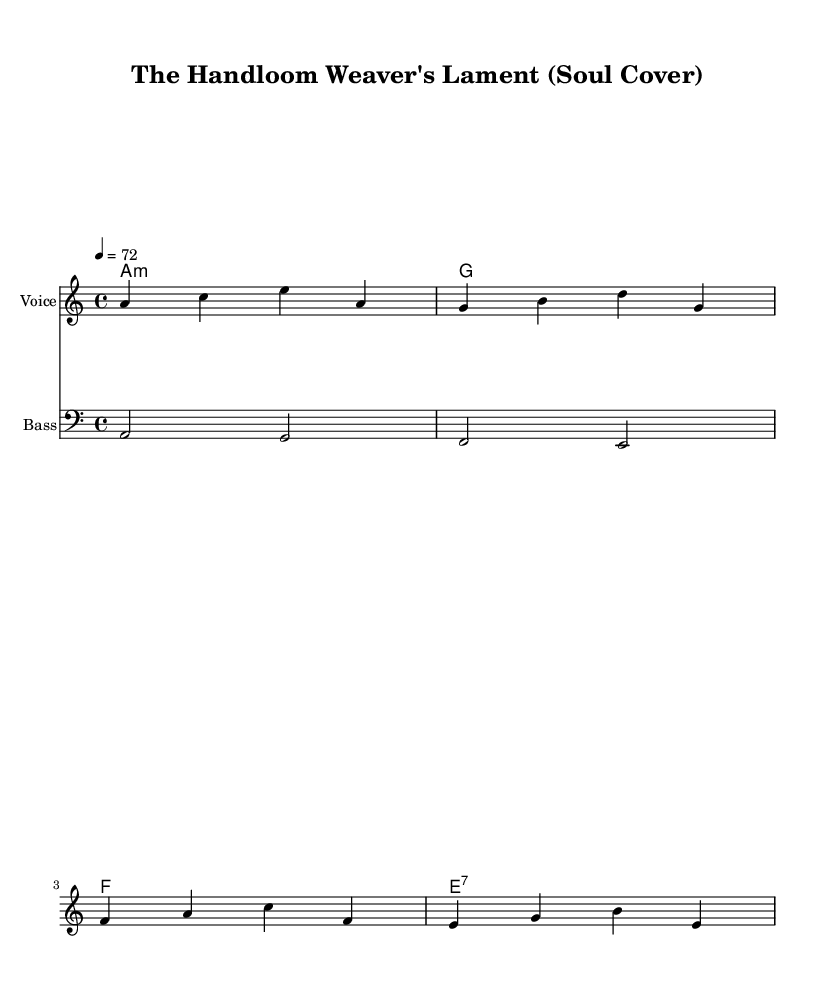What is the key signature of this music? The key signature is A minor, which is indicated by the absence of sharps and flats. A minor is the relative minor of C major.
Answer: A minor What is the time signature of this music? The time signature is 4/4, which indicates that there are four beats in each measure, and the quarter note gets one beat. This common time signature is identified at the beginning of the piece.
Answer: 4/4 What is the tempo marking indicated in the sheet music? The tempo marking shows 4 equals 72, meaning the music should be played at a speed of 72 beats per minute, which is a moderate pace.
Answer: 72 What chord follows the A minor in the harmonies? The chord that follows A minor in the listed chord progression is G major, which is the second chord in the sequence. This can be seen as the music moves through the harmonies.
Answer: G How many measures are in the melody section? The melody section contains four measures, as indicated by the grouping of four sets of notes written before the bar lines. Each grouping constitutes a measure.
Answer: 4 What type of music is this arrangement influenced by? This arrangement is influenced by Soul music, which is characterized by its emotive vocal style and the integration of various musical elements. This is established by the genre context explicitly mentioned.
Answer: Soul What is the first note of the melody? The first note of the melody is A, which is highlighted at the start of the melodic line in the sheet music.
Answer: A 